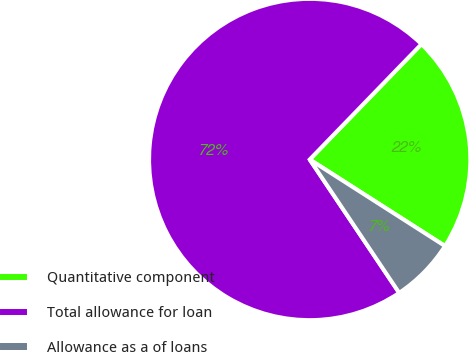<chart> <loc_0><loc_0><loc_500><loc_500><pie_chart><fcel>Quantitative component<fcel>Total allowance for loan<fcel>Allowance as a of loans<nl><fcel>21.81%<fcel>71.65%<fcel>6.54%<nl></chart> 